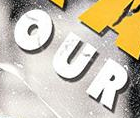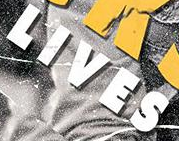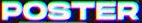Read the text from these images in sequence, separated by a semicolon. OUR; LIVES; POSTER 